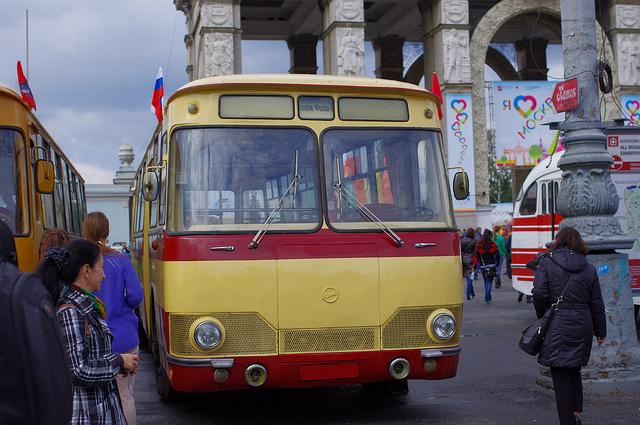Was this photo taken at night?
Answer briefly. No. What type of vehicle is this?
Be succinct. Bus. What are the colors on the bus?
Concise answer only. Yellow and red. 